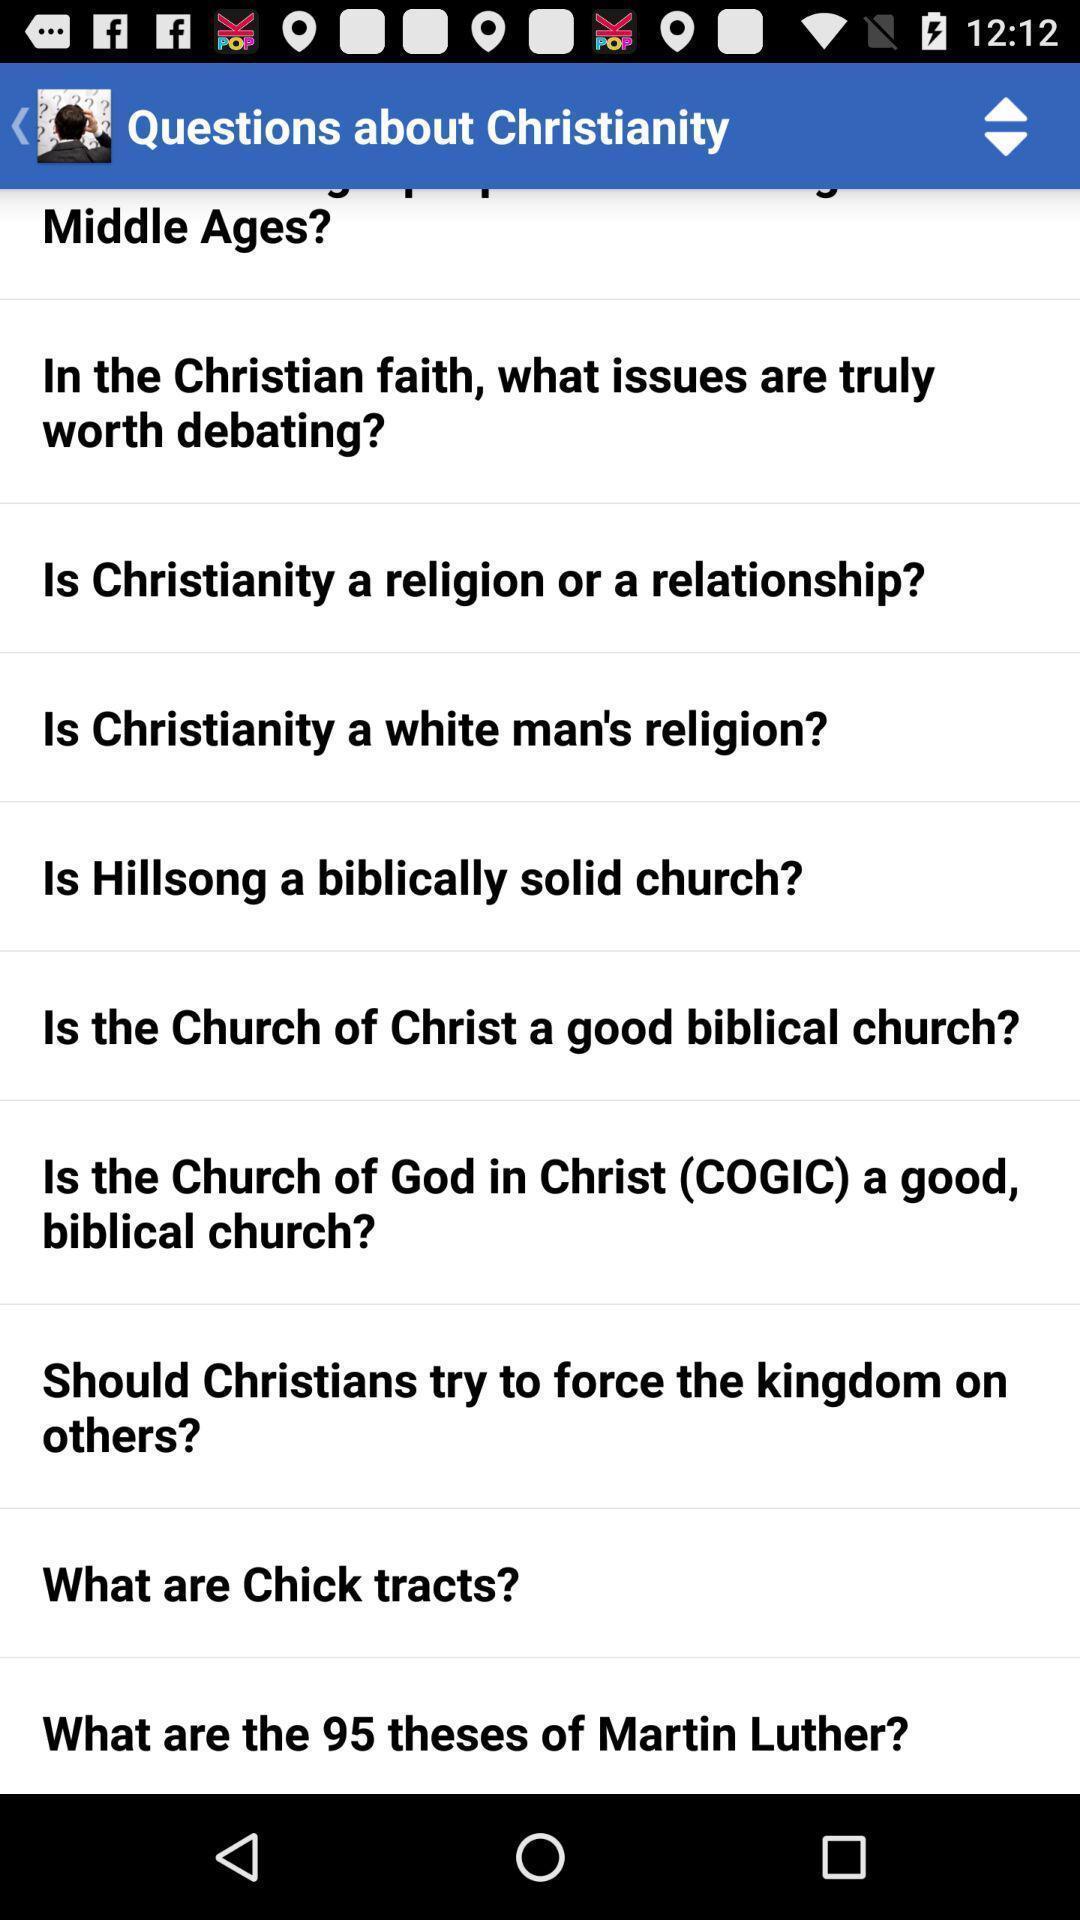Explain what's happening in this screen capture. Screen displaying list of questions about christianity. 